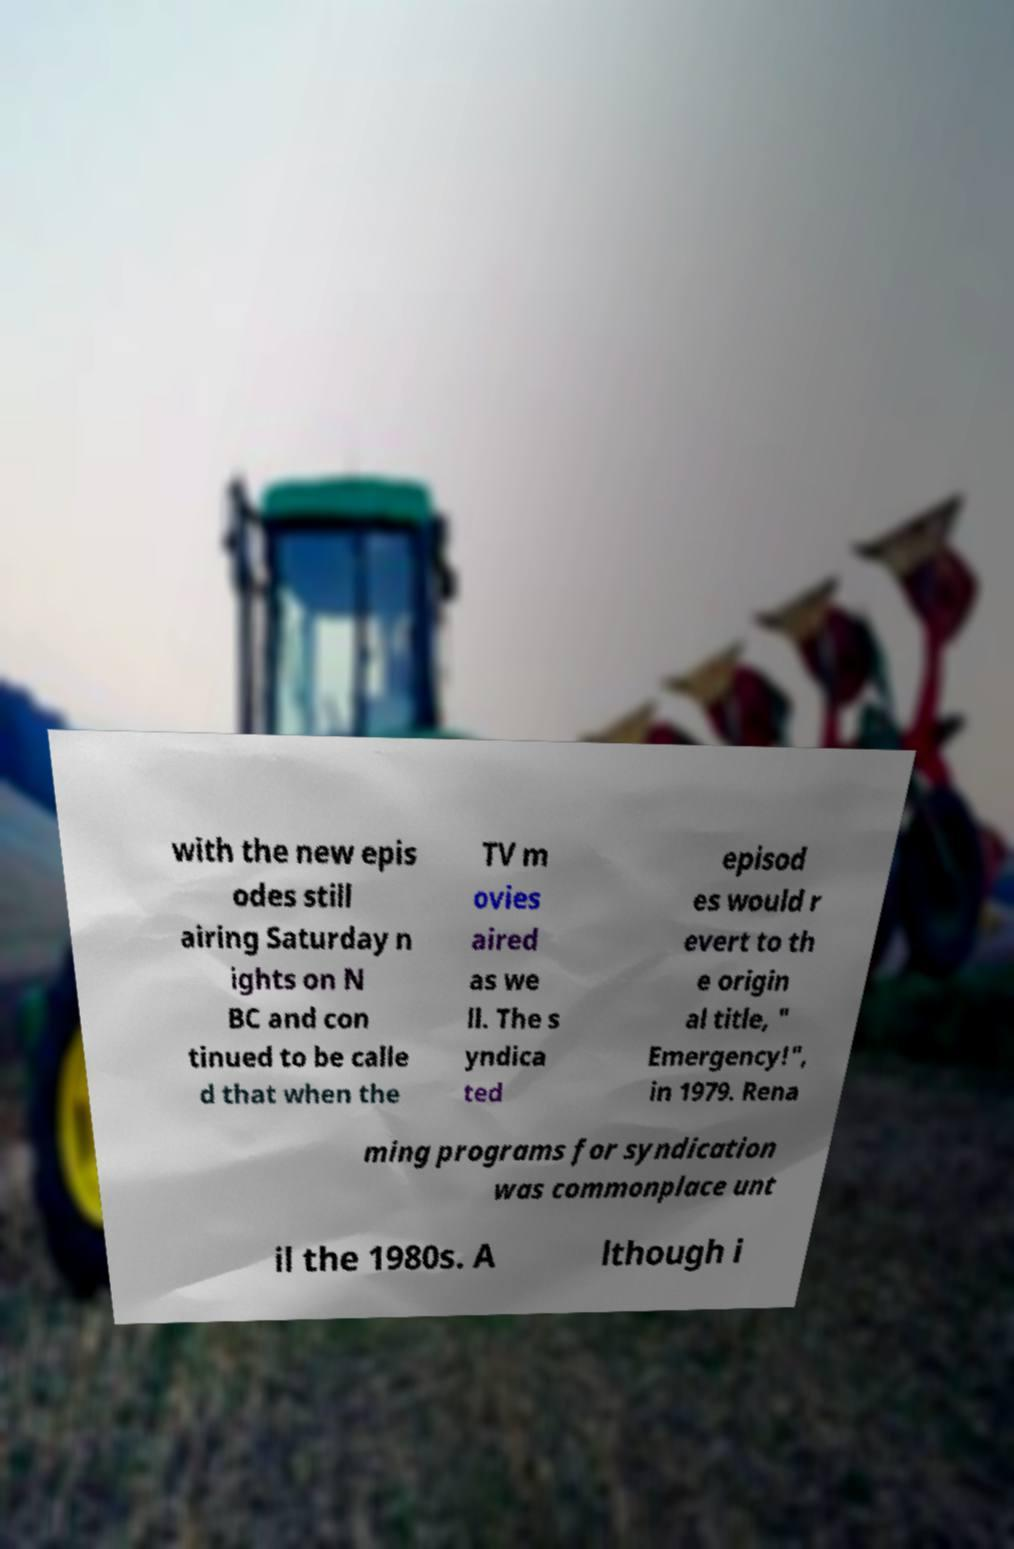Can you accurately transcribe the text from the provided image for me? with the new epis odes still airing Saturday n ights on N BC and con tinued to be calle d that when the TV m ovies aired as we ll. The s yndica ted episod es would r evert to th e origin al title, " Emergency!", in 1979. Rena ming programs for syndication was commonplace unt il the 1980s. A lthough i 